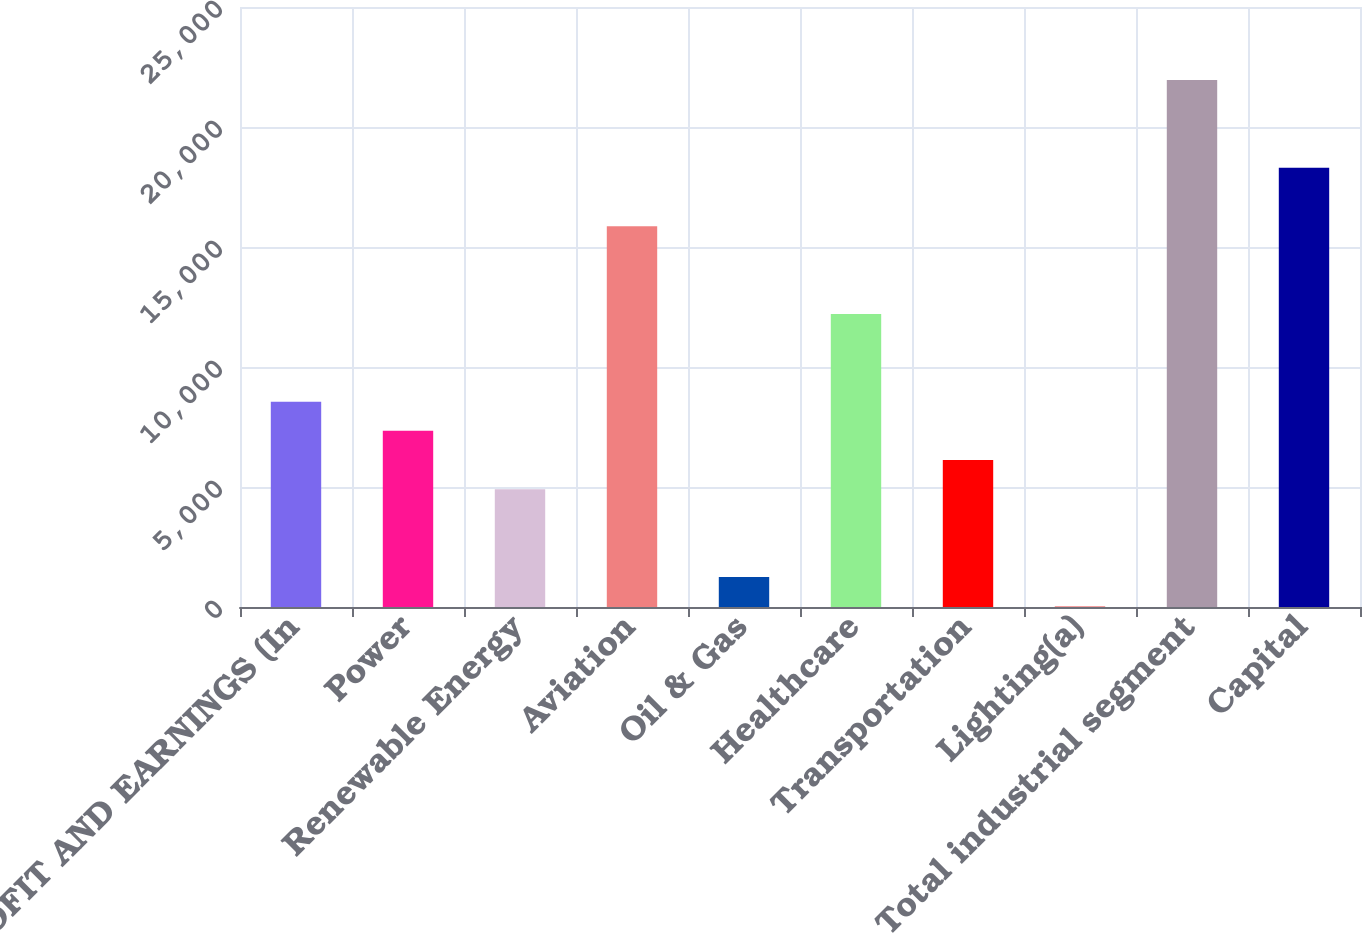Convert chart to OTSL. <chart><loc_0><loc_0><loc_500><loc_500><bar_chart><fcel>PROFIT AND EARNINGS (In<fcel>Power<fcel>Renewable Energy<fcel>Aviation<fcel>Oil & Gas<fcel>Healthcare<fcel>Transportation<fcel>Lighting(a)<fcel>Total industrial segment<fcel>Capital<nl><fcel>8557.2<fcel>7338.6<fcel>4901.4<fcel>15868.8<fcel>1245.6<fcel>12213<fcel>6120<fcel>27<fcel>21961.8<fcel>18306<nl></chart> 